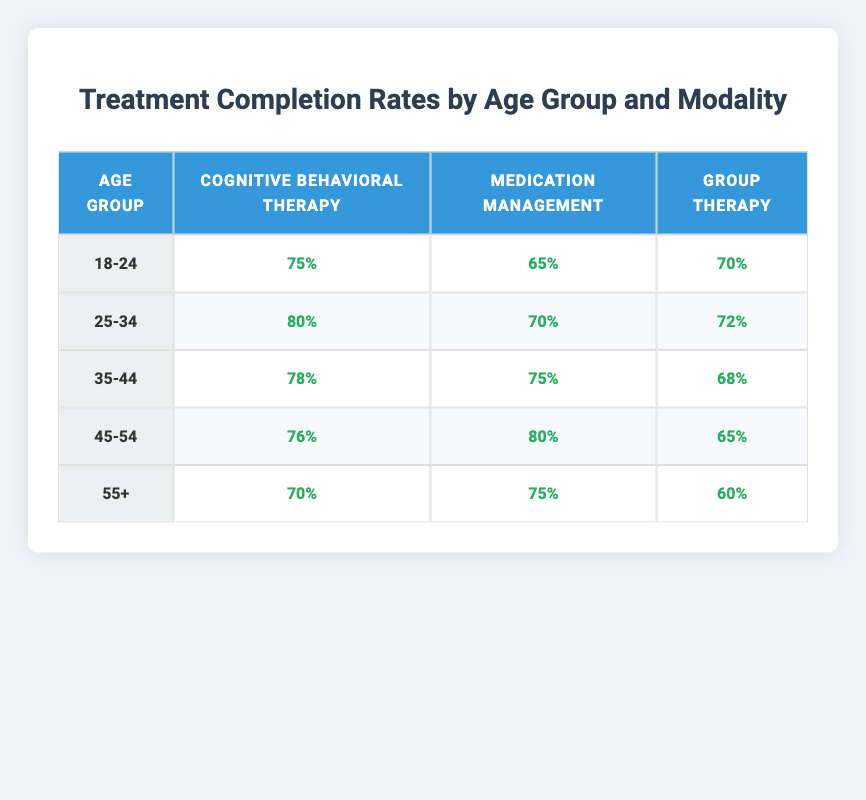What is the treatment completion rate for Cognitive Behavioral Therapy in the age group 25-34? The table shows that for the age group 25-34, the completion rate for Cognitive Behavioral Therapy is listed directly under that row and column, which is 80%.
Answer: 80% Which treatment modality has the highest completion rate for the age group 45-54? By examining the 45-54 row, we see the completion rates for each modality: 76% for Cognitive Behavioral Therapy, 80% for Medication Management, and 65% for Group Therapy. The highest rate is 80% for Medication Management.
Answer: Medication Management Is the completion rate for Group Therapy higher in the age group 35-44 than in the age group 18-24? In the 35-44 age group, the Group Therapy completion rate is 68%, while in the 18-24 age group, it is 70%. Since 68% is less than 70%, the completion rate for Group Therapy is not higher in 35-44 than in 18-24.
Answer: No What is the average treatment completion rate for Medication Management across all age groups? To find the average, we will sum the completion rates for Medication Management across all age groups: 65% (18-24) + 70% (25-34) + 75% (35-44) + 80% (45-54) + 75% (55+) = 365%. We then divide by 5 age groups to get the average: 365% / 5 = 73%.
Answer: 73% For the age group 55+, which treatment modality has the lowest completion rate? In the 55+ row, we can see that the completion rates are 70% for Cognitive Behavioral Therapy, 75% for Medication Management, and 60% for Group Therapy. The lowest rate among these is 60% for Group Therapy.
Answer: Group Therapy 